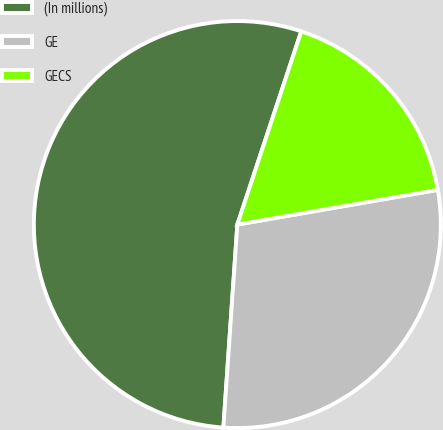<chart> <loc_0><loc_0><loc_500><loc_500><pie_chart><fcel>(In millions)<fcel>GE<fcel>GECS<nl><fcel>53.99%<fcel>28.82%<fcel>17.19%<nl></chart> 